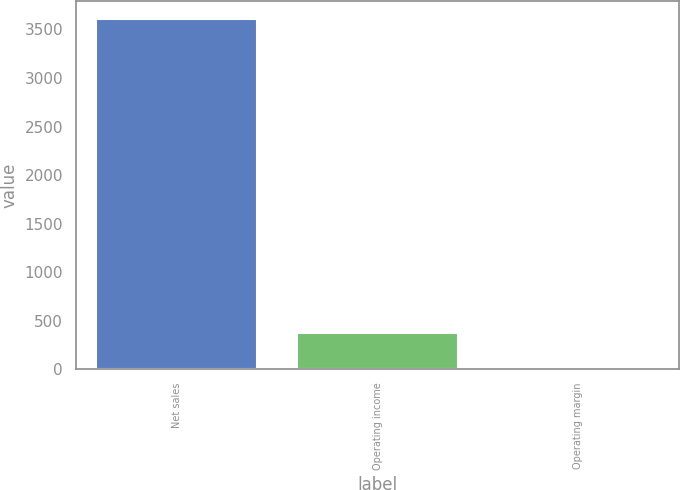Convert chart to OTSL. <chart><loc_0><loc_0><loc_500><loc_500><bar_chart><fcel>Net sales<fcel>Operating income<fcel>Operating margin<nl><fcel>3612<fcel>369.39<fcel>9.1<nl></chart> 